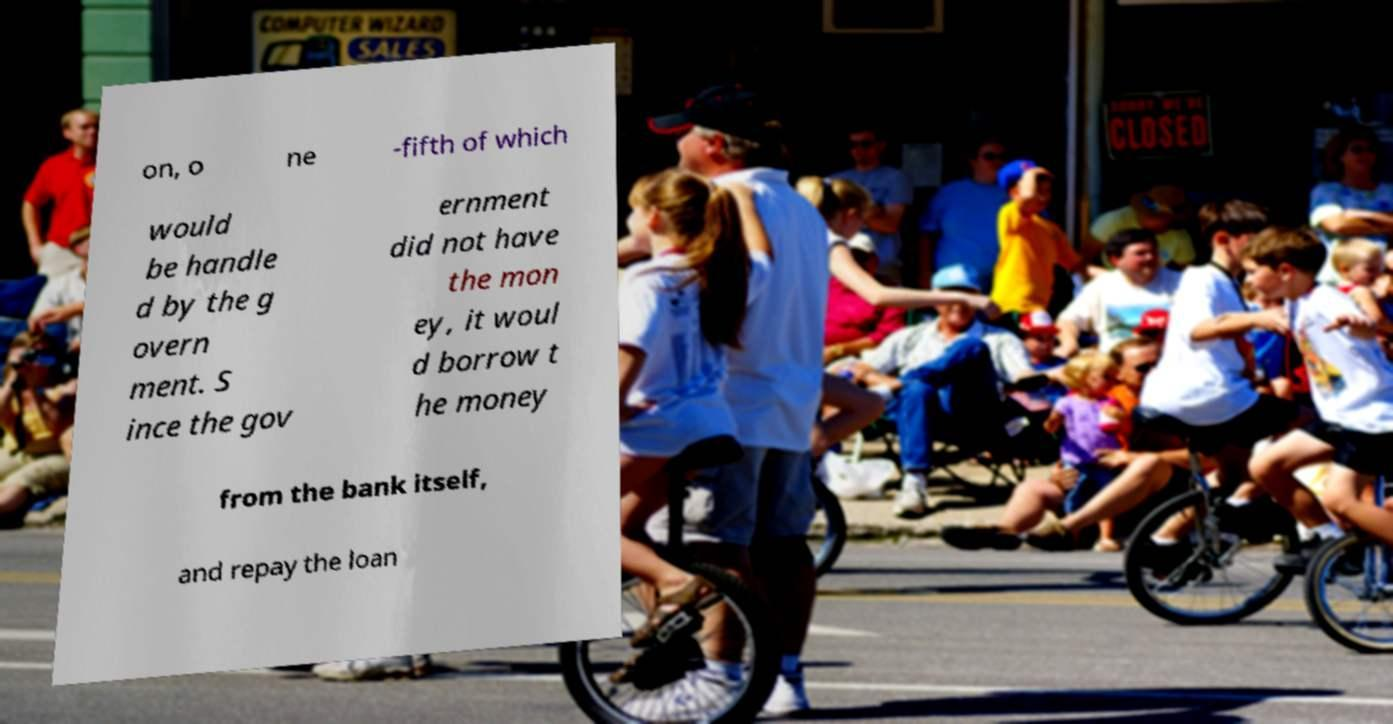Could you extract and type out the text from this image? on, o ne -fifth of which would be handle d by the g overn ment. S ince the gov ernment did not have the mon ey, it woul d borrow t he money from the bank itself, and repay the loan 